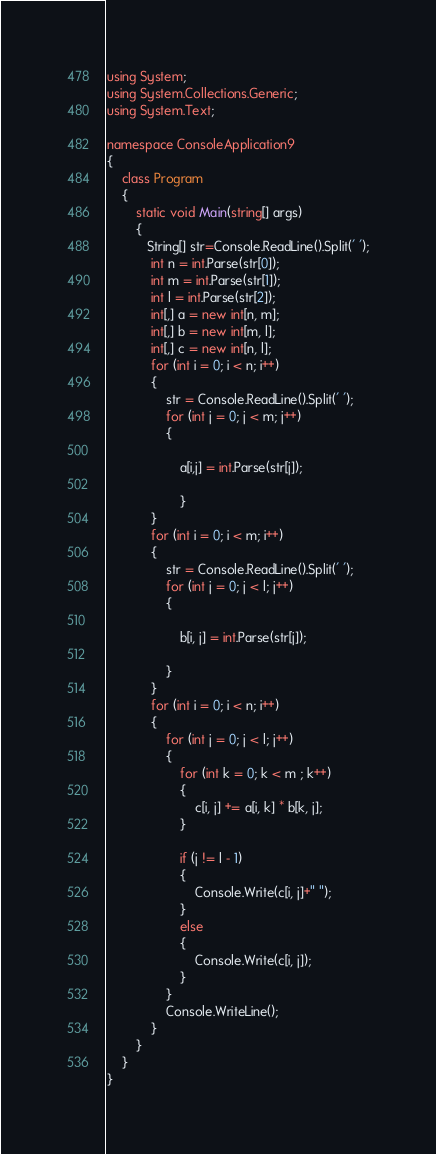Convert code to text. <code><loc_0><loc_0><loc_500><loc_500><_C#_>using System;
using System.Collections.Generic;
using System.Text;

namespace ConsoleApplication9
{
    class Program
    {
        static void Main(string[] args)
        {
           String[] str=Console.ReadLine().Split(' ');
            int n = int.Parse(str[0]);
            int m = int.Parse(str[1]);
            int l = int.Parse(str[2]); 
            int[,] a = new int[n, m];
            int[,] b = new int[m, l];
            int[,] c = new int[n, l];
            for (int i = 0; i < n; i++)
            {
                str = Console.ReadLine().Split(' ');
                for (int j = 0; j < m; j++)
                {
                    
                    a[i,j] = int.Parse(str[j]);
 
                    }
            }
            for (int i = 0; i < m; i++)
            {
                str = Console.ReadLine().Split(' ');
                for (int j = 0; j < l; j++)
                {
                   
                    b[i, j] = int.Parse(str[j]);

                }
            }
            for (int i = 0; i < n; i++)
            {
                for (int j = 0; j < l; j++)
                {
                    for (int k = 0; k < m ; k++)
                    {
                        c[i, j] += a[i, k] * b[k, j];
                    }

                    if (j != l - 1)
                    {
                        Console.Write(c[i, j]+" ");
                    }
                    else
                    {
                        Console.Write(c[i, j]);
                    }
                }
                Console.WriteLine();
            }
        }
    }
}</code> 